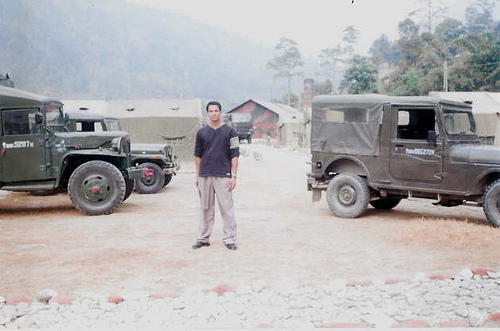Are there any quality issues with this image? The image appears to be of low resolution and somewhat overexposed, which affects the visibility of details. The colors seem washed out, and there is a noticeable graininess throughout the photograph. Moreover, the focus is soft, lacking sharpness in the foreground where the person stands as well as in the background elements like the vehicles and the structures. 